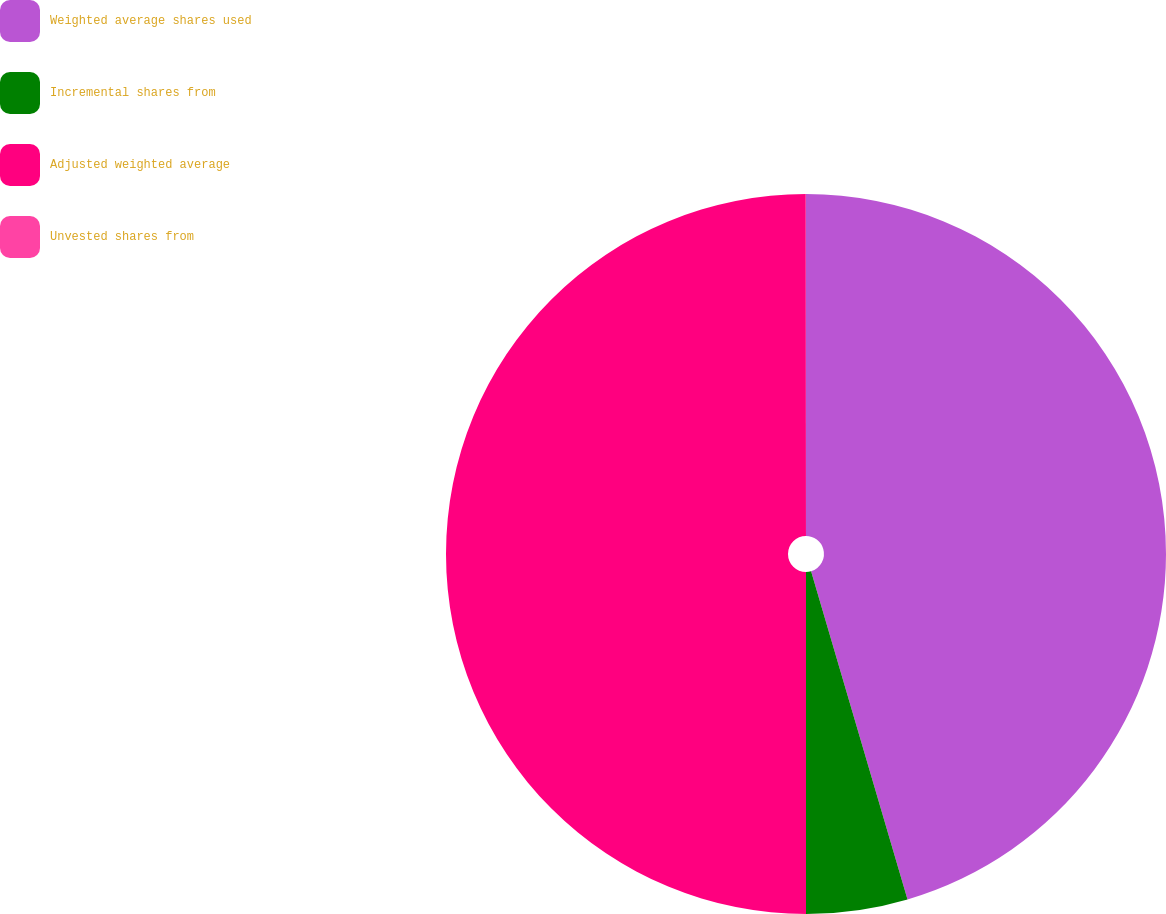<chart> <loc_0><loc_0><loc_500><loc_500><pie_chart><fcel>Weighted average shares used<fcel>Incremental shares from<fcel>Adjusted weighted average<fcel>Unvested shares from<nl><fcel>45.45%<fcel>4.55%<fcel>49.99%<fcel>0.01%<nl></chart> 